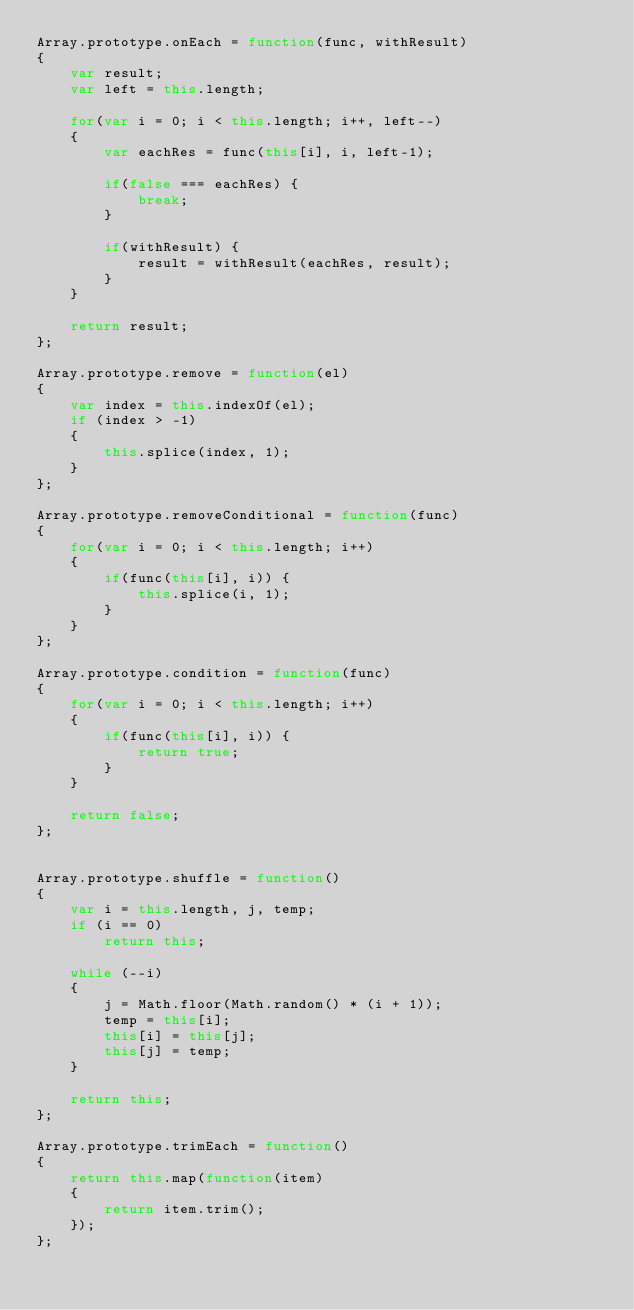<code> <loc_0><loc_0><loc_500><loc_500><_JavaScript_>Array.prototype.onEach = function(func, withResult) 
{
	var result;
	var left = this.length;

	for(var i = 0; i < this.length; i++, left--) 
	{
		var eachRes = func(this[i], i, left-1);

		if(false === eachRes) {
			break;
		}

		if(withResult) {
			result = withResult(eachRes, result);
		}
	}

	return result;
};

Array.prototype.remove = function(el) 
{
	var index = this.indexOf(el);
	if (index > -1) 
	{
		this.splice(index, 1);
	}
};

Array.prototype.removeConditional = function(func) 
{
	for(var i = 0; i < this.length; i++) 
	{
		if(func(this[i], i)) {
			this.splice(i, 1);
		}
	}
};

Array.prototype.condition = function(func) 
{
	for(var i = 0; i < this.length; i++) 
	{
		if(func(this[i], i)) {
			return true;
		}
	}
	
	return false;
};


Array.prototype.shuffle = function() 
{
	var i = this.length, j, temp;
	if (i == 0)
		return this;
	
	while (--i) 
	{
		j = Math.floor(Math.random() * (i + 1));
		temp = this[i];
		this[i] = this[j];
		this[j] = temp;
	}
	
	return this;
};

Array.prototype.trimEach = function() 
{
	return this.map(function(item) 
	{
		return item.trim();
	});
};</code> 